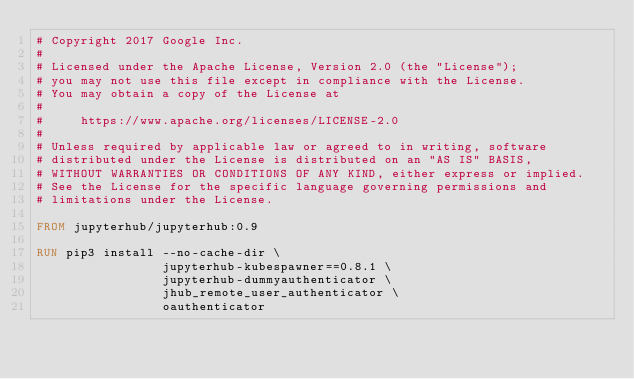<code> <loc_0><loc_0><loc_500><loc_500><_Dockerfile_># Copyright 2017 Google Inc.
#
# Licensed under the Apache License, Version 2.0 (the "License");
# you may not use this file except in compliance with the License.
# You may obtain a copy of the License at
#
#     https://www.apache.org/licenses/LICENSE-2.0
#
# Unless required by applicable law or agreed to in writing, software
# distributed under the License is distributed on an "AS IS" BASIS,
# WITHOUT WARRANTIES OR CONDITIONS OF ANY KIND, either express or implied.
# See the License for the specific language governing permissions and
# limitations under the License.

FROM jupyterhub/jupyterhub:0.9

RUN pip3 install --no-cache-dir \                 
                 jupyterhub-kubespawner==0.8.1 \
                 jupyterhub-dummyauthenticator \
                 jhub_remote_user_authenticator \
                 oauthenticator</code> 